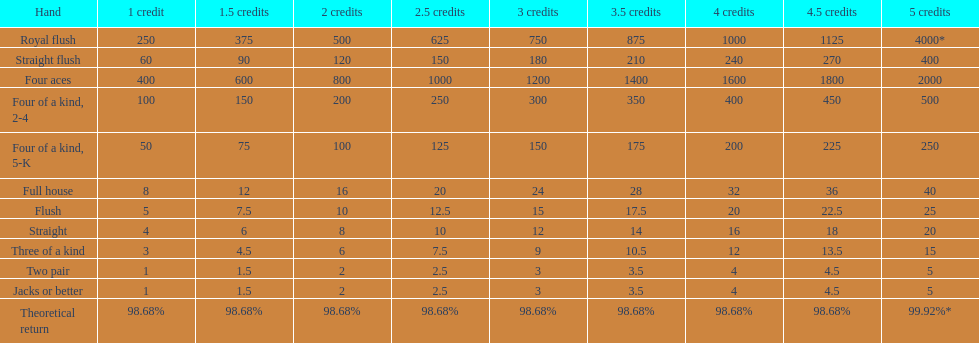What is the difference of payout on 3 credits, between a straight flush and royal flush? 570. 